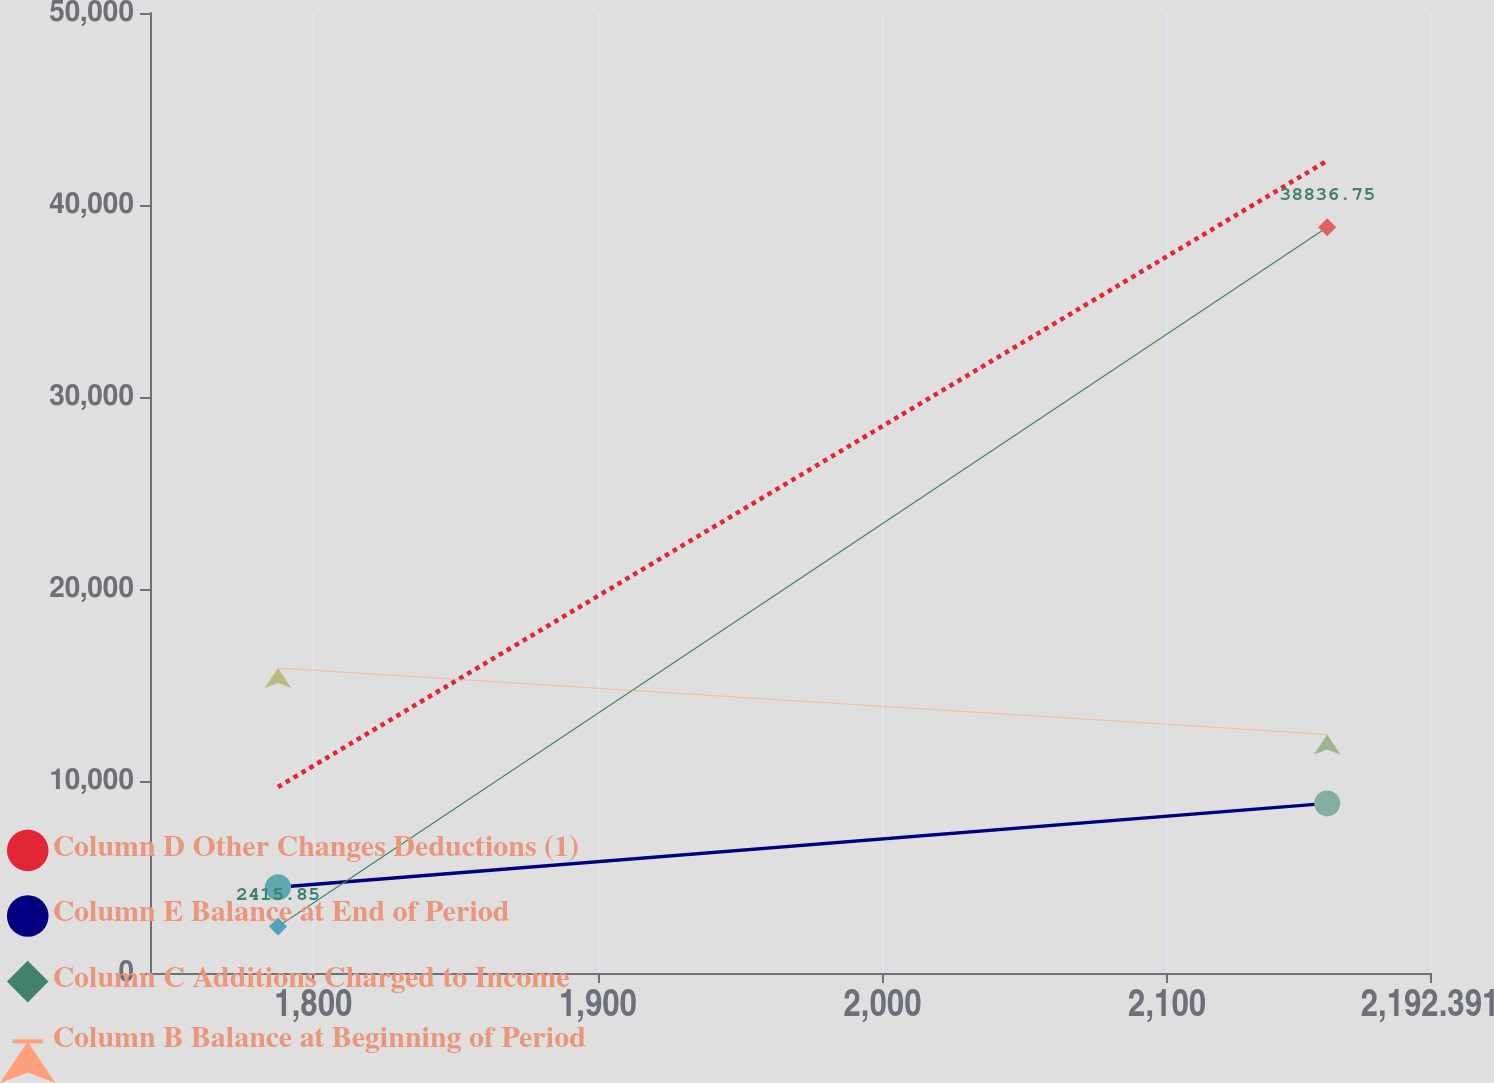<chart> <loc_0><loc_0><loc_500><loc_500><line_chart><ecel><fcel>Column D Other Changes Deductions (1)<fcel>Column E Balance at End of Period<fcel>Column C Additions Charged to Income<fcel>Column B Balance at Beginning of Period<nl><fcel>1787.58<fcel>9688.26<fcel>4464.99<fcel>2415.85<fcel>15884.6<nl><fcel>2156.26<fcel>42306.1<fcel>8833.38<fcel>38836.8<fcel>12423.9<nl><fcel>2237.37<fcel>39289.8<fcel>7793.4<fcel>6057.94<fcel>42118.5<nl></chart> 